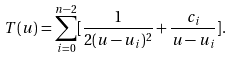Convert formula to latex. <formula><loc_0><loc_0><loc_500><loc_500>T ( u ) = \sum _ { i = 0 } ^ { n - 2 } [ \frac { 1 } { 2 ( u - u _ { i } ) ^ { 2 } } + \frac { c _ { i } } { u - u _ { i } } ] .</formula> 